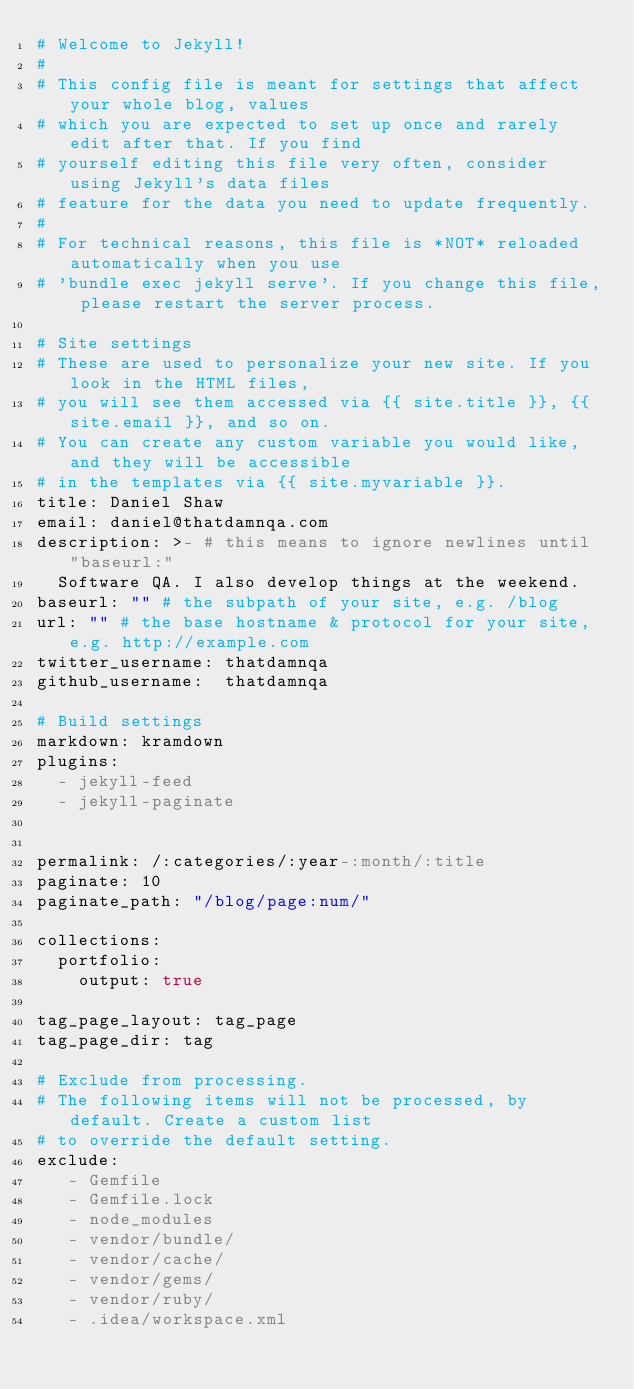<code> <loc_0><loc_0><loc_500><loc_500><_YAML_># Welcome to Jekyll!
#
# This config file is meant for settings that affect your whole blog, values
# which you are expected to set up once and rarely edit after that. If you find
# yourself editing this file very often, consider using Jekyll's data files
# feature for the data you need to update frequently.
#
# For technical reasons, this file is *NOT* reloaded automatically when you use
# 'bundle exec jekyll serve'. If you change this file, please restart the server process.

# Site settings
# These are used to personalize your new site. If you look in the HTML files,
# you will see them accessed via {{ site.title }}, {{ site.email }}, and so on.
# You can create any custom variable you would like, and they will be accessible
# in the templates via {{ site.myvariable }}.
title: Daniel Shaw
email: daniel@thatdamnqa.com
description: >- # this means to ignore newlines until "baseurl:"
  Software QA. I also develop things at the weekend.
baseurl: "" # the subpath of your site, e.g. /blog
url: "" # the base hostname & protocol for your site, e.g. http://example.com
twitter_username: thatdamnqa
github_username:  thatdamnqa

# Build settings
markdown: kramdown
plugins:
  - jekyll-feed
  - jekyll-paginate


permalink: /:categories/:year-:month/:title
paginate: 10
paginate_path: "/blog/page:num/"

collections:
  portfolio:
    output: true

tag_page_layout: tag_page
tag_page_dir: tag

# Exclude from processing.
# The following items will not be processed, by default. Create a custom list
# to override the default setting.
exclude:
   - Gemfile
   - Gemfile.lock
   - node_modules
   - vendor/bundle/
   - vendor/cache/
   - vendor/gems/
   - vendor/ruby/
   - .idea/workspace.xml</code> 